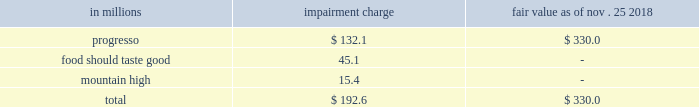Valuation of long-lived assets we estimate the useful lives of long-lived assets and make estimates concerning undiscounted cash flows to review for impairment whenever events or changes in circumstances indicate that the carrying amount of an asset ( or asset group ) may not be recoverable .
Fair value is measured using discounted cash flows or independent appraisals , as appropriate .
Intangible assets goodwill and other indefinite-lived intangible assets are not subject to amortization and are tested for impairment annually and whenever events or changes in circumstances indicate that impairment may have occurred .
Our estimates of fair value for goodwill impairment testing are determined based on a discounted cash flow model .
We use inputs from our long-range planning process to determine growth rates for sales and profits .
We also make estimates of discount rates , perpetuity growth assumptions , market comparables , and other factors .
We evaluate the useful lives of our other intangible assets , mainly brands , to determine if they are finite or indefinite-lived .
Reaching a determination on useful life requires significant judgments and assumptions regarding the future effects of obsolescence , demand , competition , other economic factors ( such as the stability of the industry , known technological advances , legislative action that results in an uncertain or changing regulatory environment , and expected changes in distribution channels ) , the level of required maintenance expenditures , and the expected lives of other related groups of assets .
Intangible assets that are deemed to have definite lives are amortized on a straight-line basis , over their useful lives , generally ranging from 4 to 30 years .
Our estimate of the fair value of our brand assets is based on a discounted cash flow model using inputs which include projected revenues from our long-range plan , assumed royalty rates that could be payable if we did not own the brands , and a discount rate .
As of may 26 , 2019 , we had $ 20.6 billion of goodwill and indefinite-lived intangible assets .
While we currently believe that the fair value of each intangible exceeds its carrying value and that those intangibles so classified will contribute indefinitely to our cash flows , materially different assumptions regarding future performance of our businesses or a different weighted-average cost of capital could result in material impairment losses and amortization expense .
We performed our fiscal 2019 assessment of our intangible assets as of the first day of the second quarter of fiscal 2019 .
As a result of lower sales projections in our long-range plans for the businesses supporting the progresso , food should taste good , and mountain high brand intangible assets , we recorded the following impairment charges : in millions impairment charge fair value nov .
25 , 2018 progresso $ 132.1 $ 330.0 food should taste good 45.1 - mountain high 15.4 - .
Significant assumptions used in that assessment included our long-range cash flow projections for the businesses , royalty rates , weighted-average cost of capital rates , and tax rates. .
What was the total value of progresso before the impairment charge? 
Computations: (132.1 + 330.0)
Answer: 462.1. 